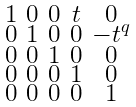Convert formula to latex. <formula><loc_0><loc_0><loc_500><loc_500>\begin{smallmatrix} 1 & 0 & 0 & t & 0 \\ 0 & 1 & 0 & 0 & - t ^ { q } \\ 0 & 0 & 1 & 0 & 0 \\ 0 & 0 & 0 & 1 & 0 \\ 0 & 0 & 0 & 0 & 1 \end{smallmatrix}</formula> 